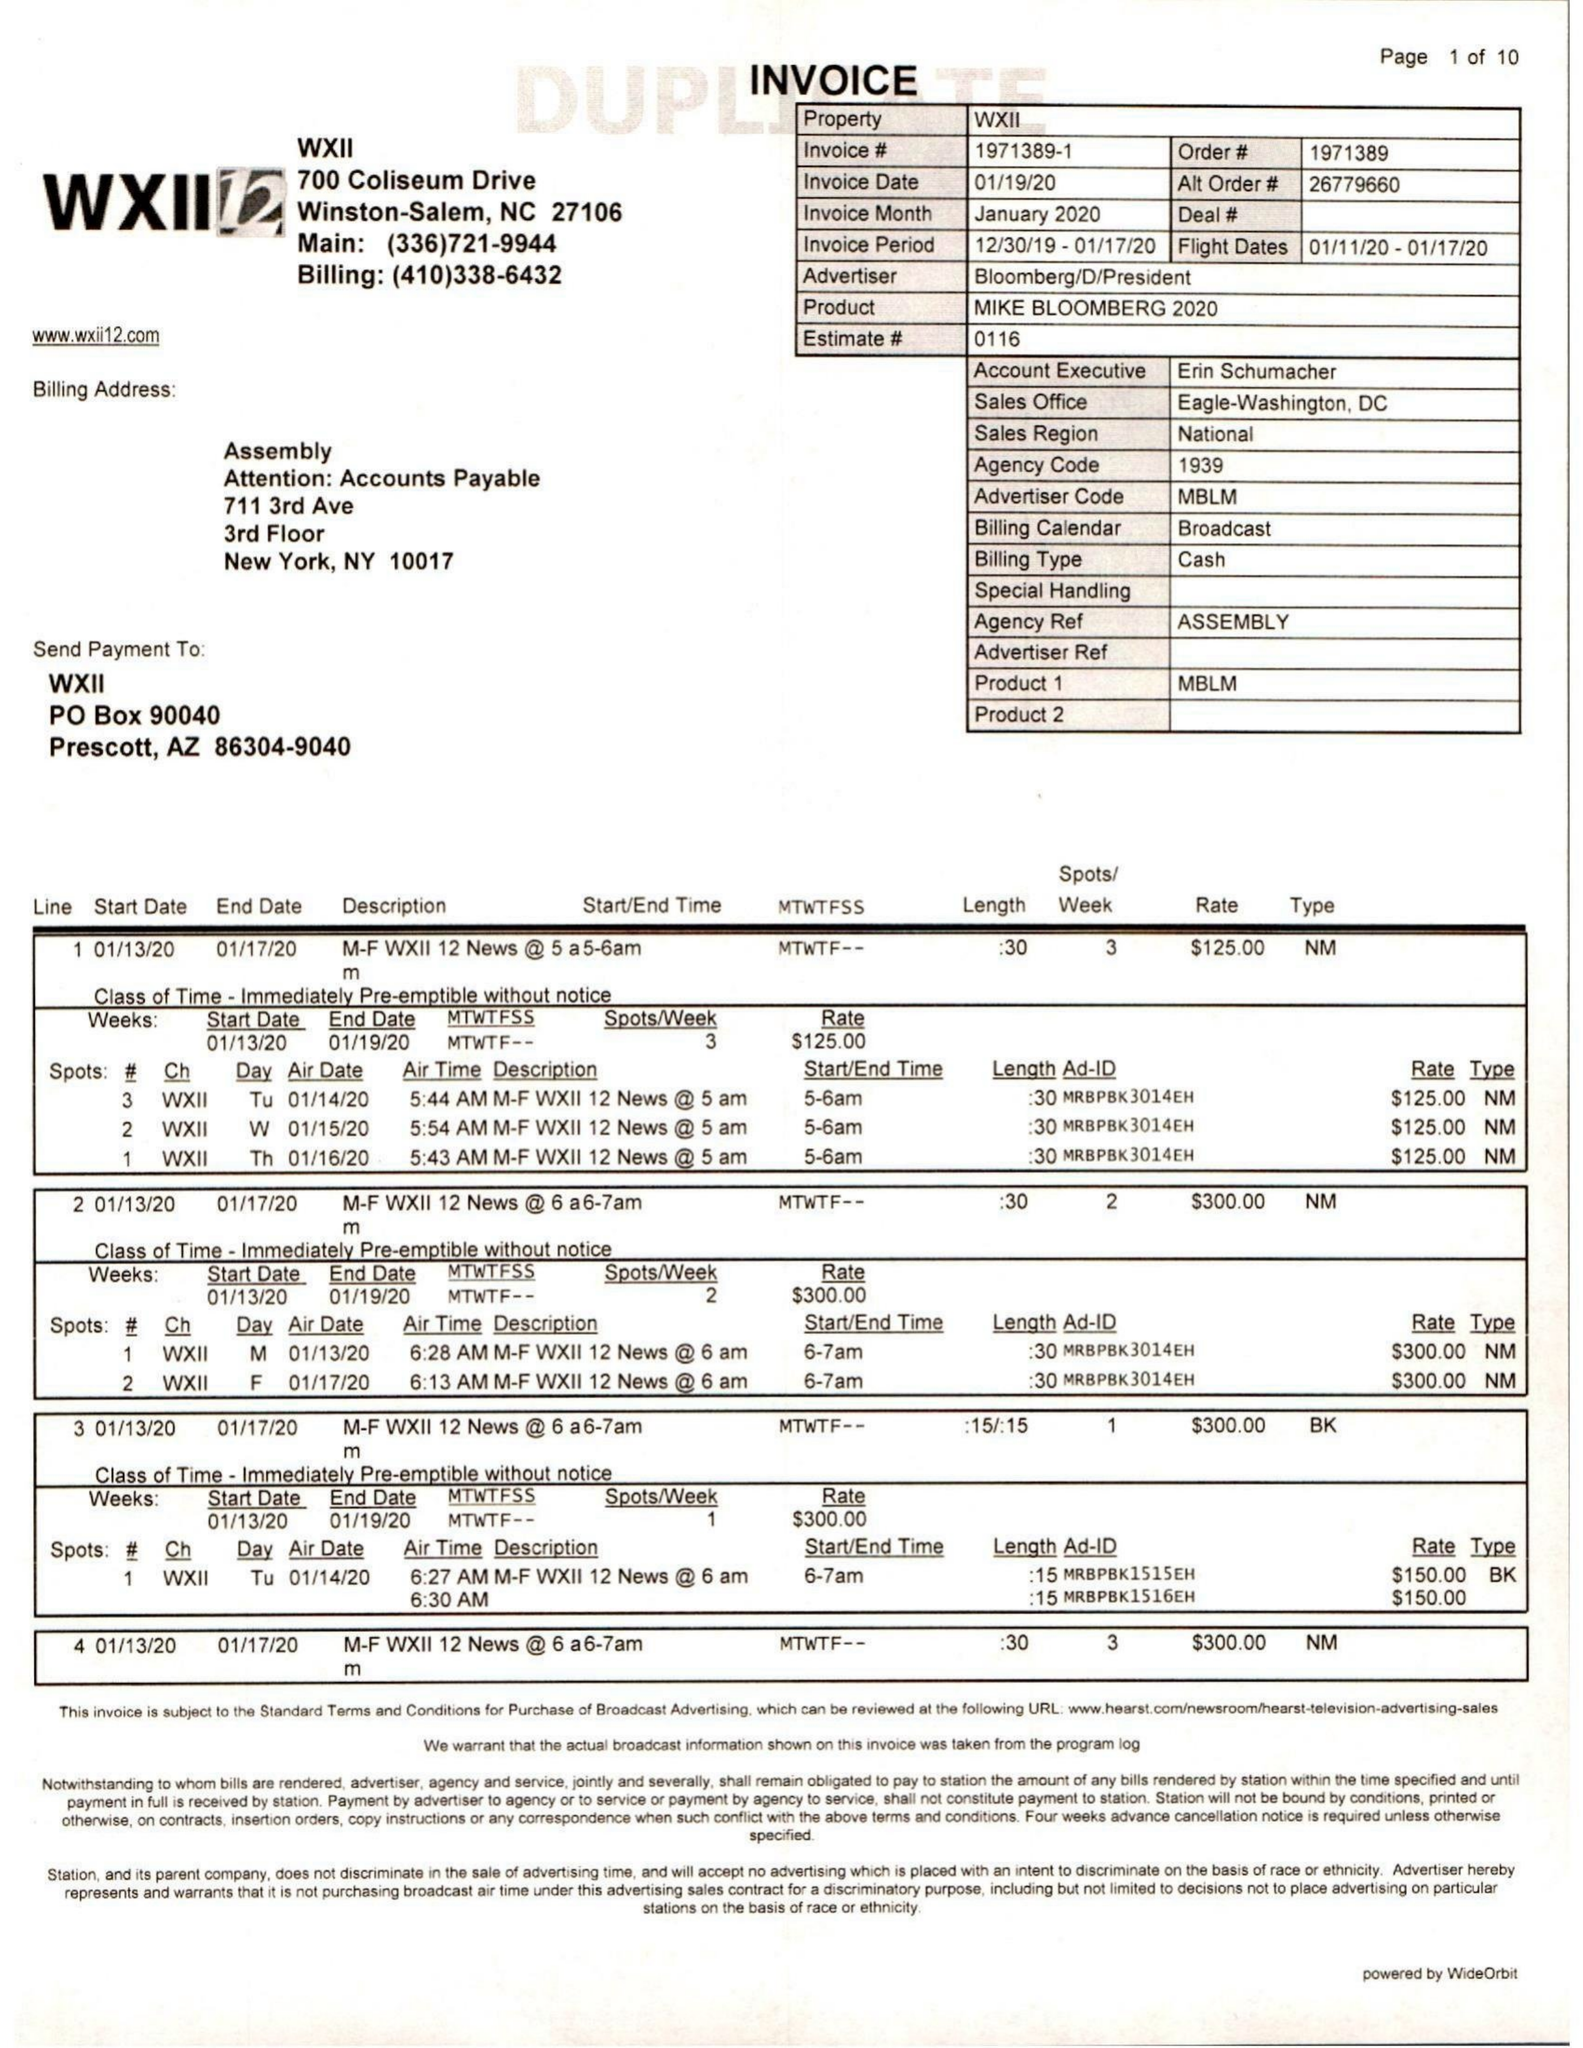What is the value for the flight_to?
Answer the question using a single word or phrase. 01/17/20 